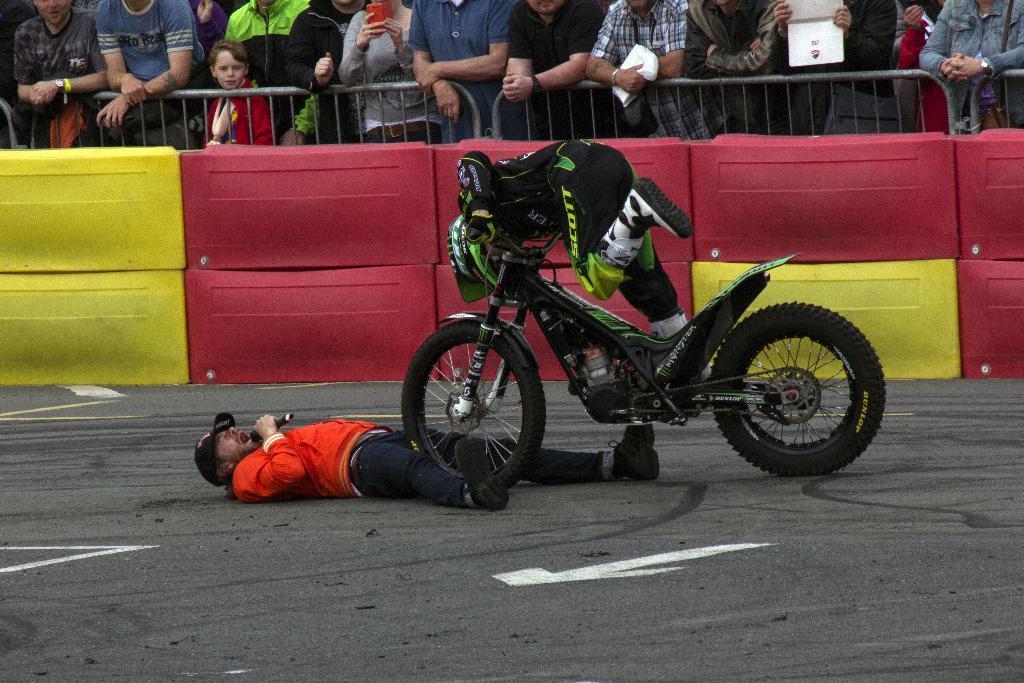How would you summarize this image in a sentence or two? As we can see in the image there are group of people standing and there is a man wearing black color shirt and riding motor cycle and the man who is laying on ground is holding mic. 